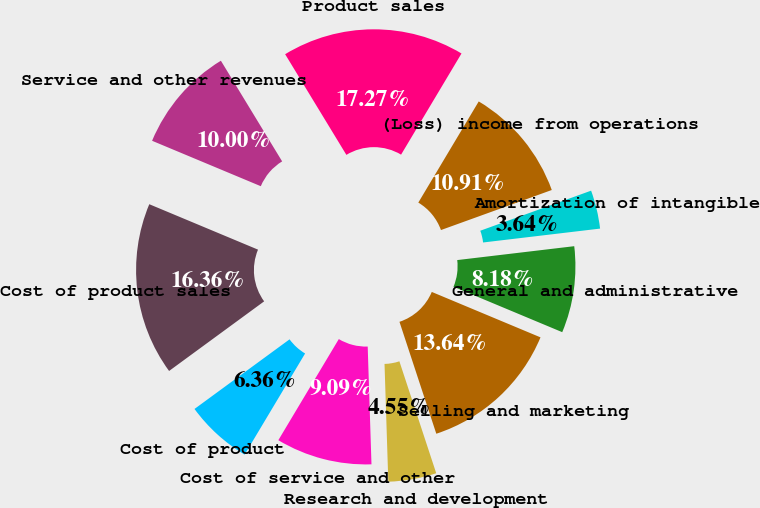<chart> <loc_0><loc_0><loc_500><loc_500><pie_chart><fcel>Product sales<fcel>Service and other revenues<fcel>Cost of product sales<fcel>Cost of product<fcel>Cost of service and other<fcel>Research and development<fcel>Selling and marketing<fcel>General and administrative<fcel>Amortization of intangible<fcel>(Loss) income from operations<nl><fcel>17.27%<fcel>10.0%<fcel>16.36%<fcel>6.36%<fcel>9.09%<fcel>4.55%<fcel>13.64%<fcel>8.18%<fcel>3.64%<fcel>10.91%<nl></chart> 